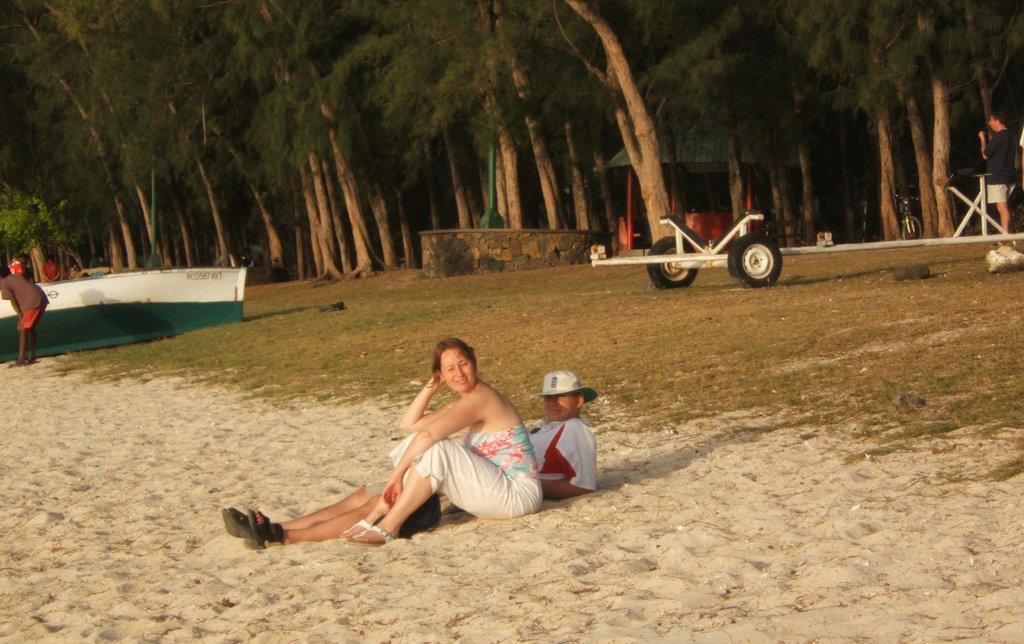Please provide a concise description of this image. In the picture we can see a beach view with a man and woman sitting on the sand surface and near it, we can see a grass surface on it, we can see a cart and behind it we can see trees, and path and a man standing on the path. 